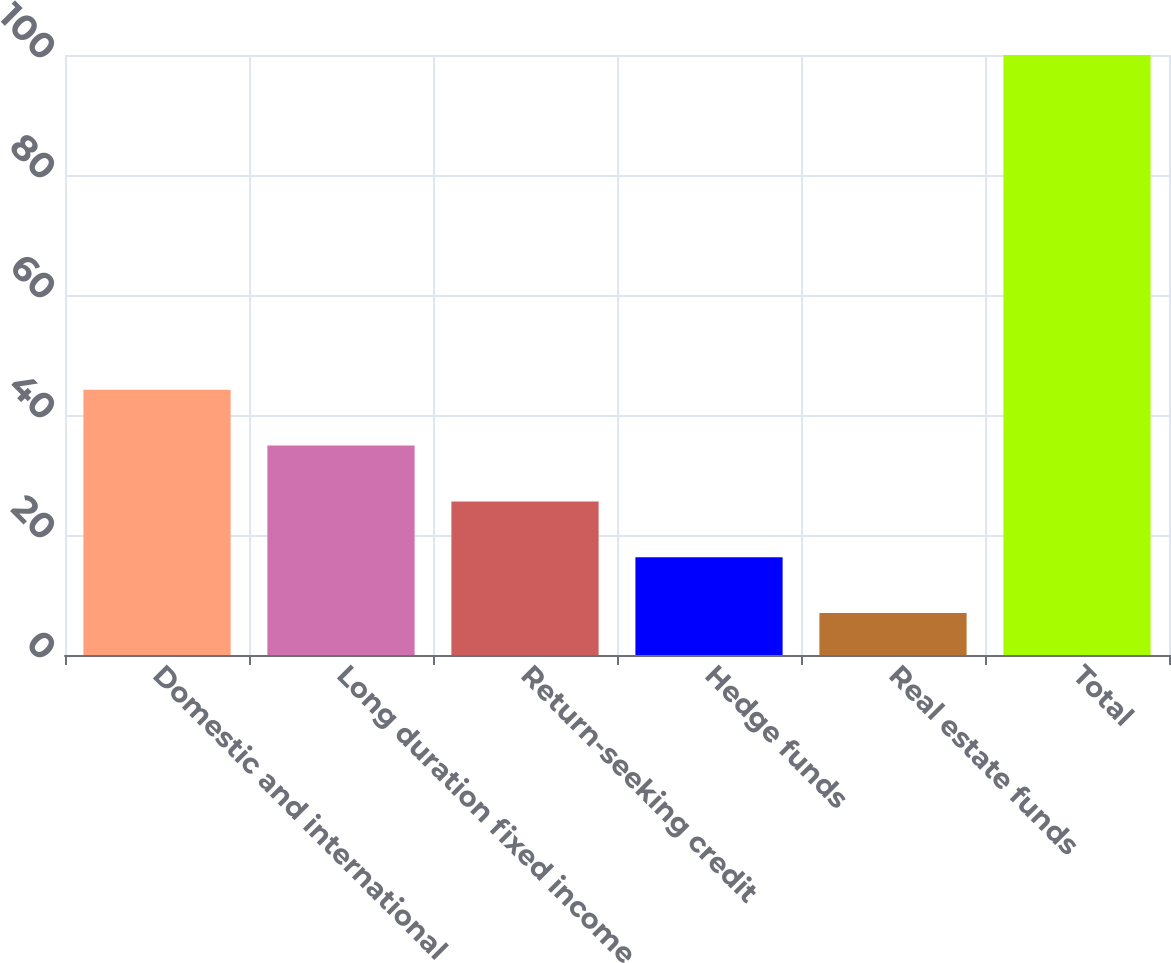Convert chart to OTSL. <chart><loc_0><loc_0><loc_500><loc_500><bar_chart><fcel>Domestic and international<fcel>Long duration fixed income<fcel>Return-seeking credit<fcel>Hedge funds<fcel>Real estate funds<fcel>Total<nl><fcel>44.2<fcel>34.9<fcel>25.6<fcel>16.3<fcel>7<fcel>100<nl></chart> 